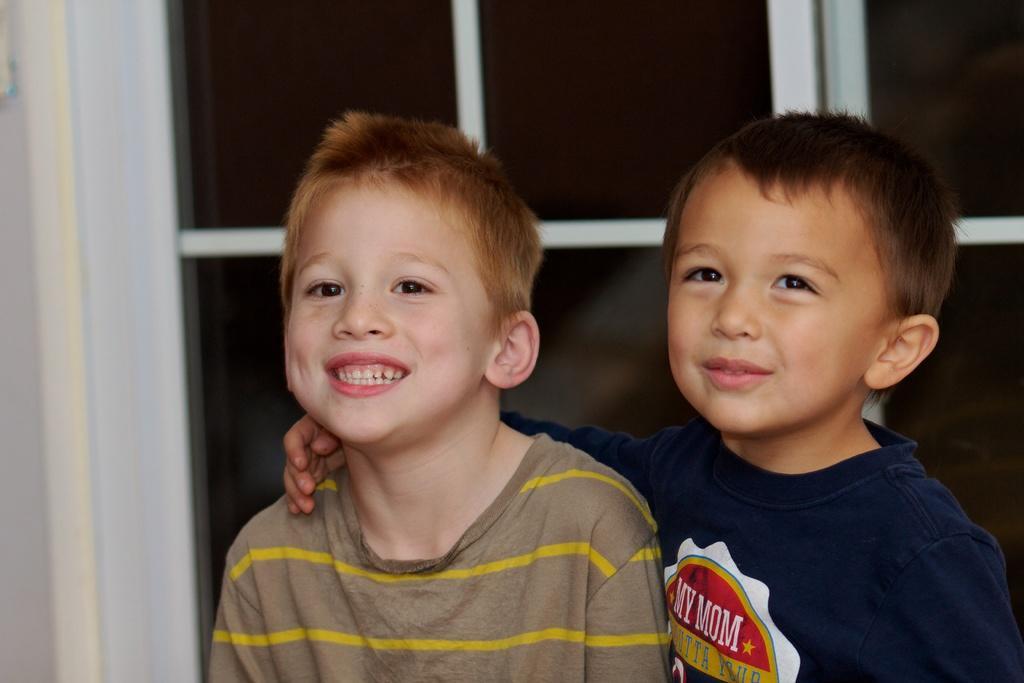How would you summarize this image in a sentence or two? This is the picture of two boys who are in front of the door. 